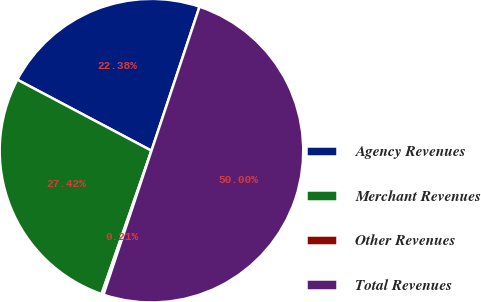<chart> <loc_0><loc_0><loc_500><loc_500><pie_chart><fcel>Agency Revenues<fcel>Merchant Revenues<fcel>Other Revenues<fcel>Total Revenues<nl><fcel>22.38%<fcel>27.42%<fcel>0.21%<fcel>50.0%<nl></chart> 